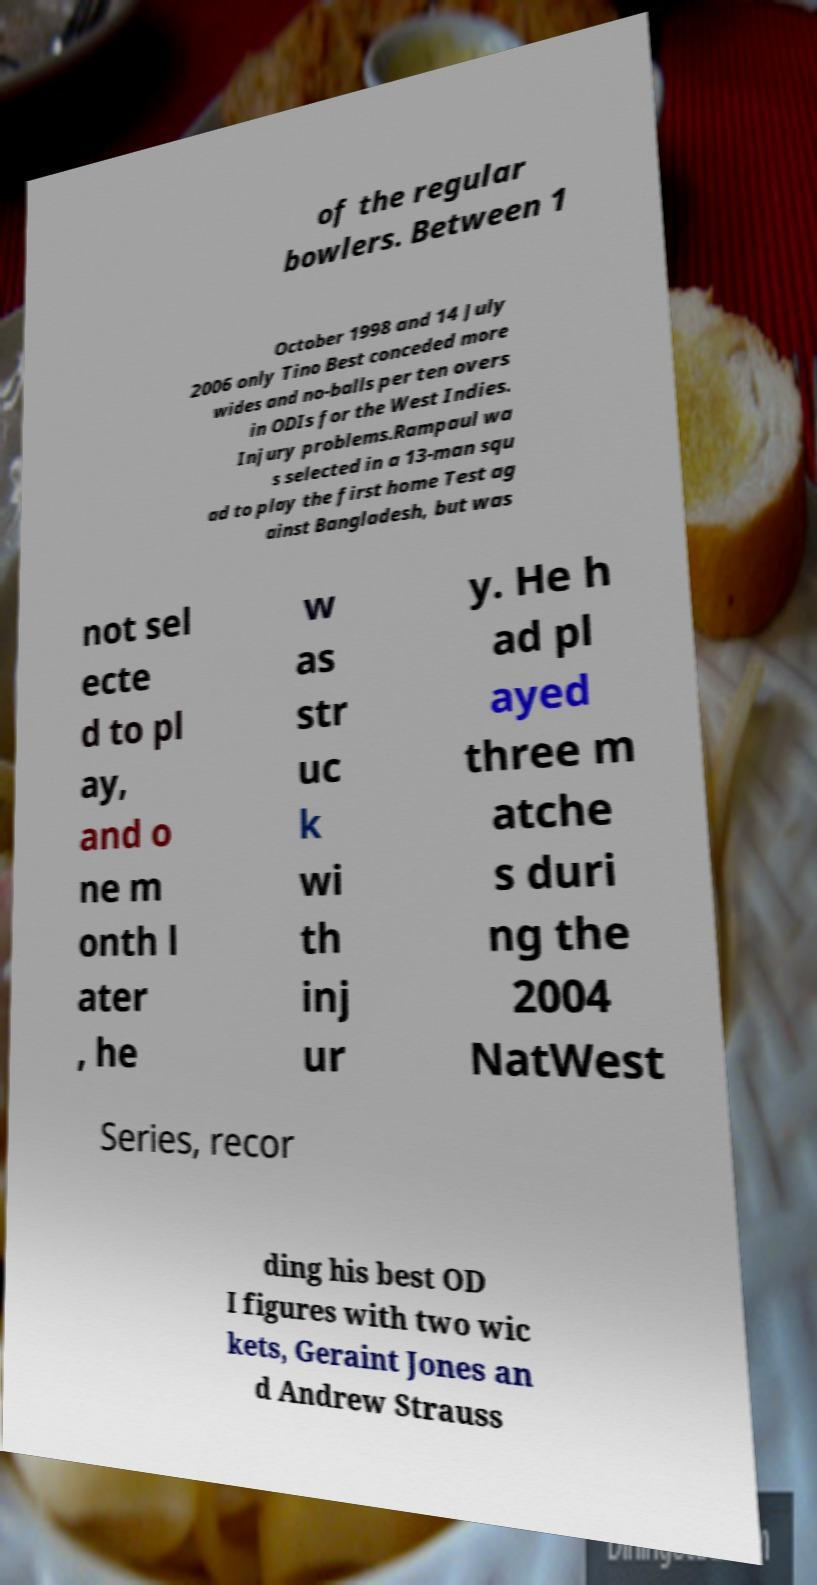I need the written content from this picture converted into text. Can you do that? of the regular bowlers. Between 1 October 1998 and 14 July 2006 only Tino Best conceded more wides and no-balls per ten overs in ODIs for the West Indies. Injury problems.Rampaul wa s selected in a 13-man squ ad to play the first home Test ag ainst Bangladesh, but was not sel ecte d to pl ay, and o ne m onth l ater , he w as str uc k wi th inj ur y. He h ad pl ayed three m atche s duri ng the 2004 NatWest Series, recor ding his best OD I figures with two wic kets, Geraint Jones an d Andrew Strauss 